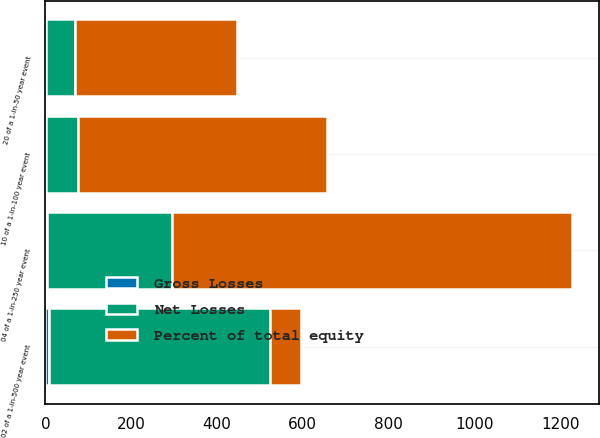Convert chart to OTSL. <chart><loc_0><loc_0><loc_500><loc_500><stacked_bar_chart><ecel><fcel>20 of a 1-in-50 year event<fcel>10 of a 1-in-100 year event<fcel>04 of a 1-in-250 year event<fcel>02 of a 1-in-500 year event<nl><fcel>Percent of total equity<fcel>378<fcel>580<fcel>932<fcel>74<nl><fcel>Net Losses<fcel>68<fcel>74<fcel>291<fcel>514<nl><fcel>Gross Losses<fcel>1.1<fcel>1.2<fcel>4.8<fcel>8.5<nl></chart> 